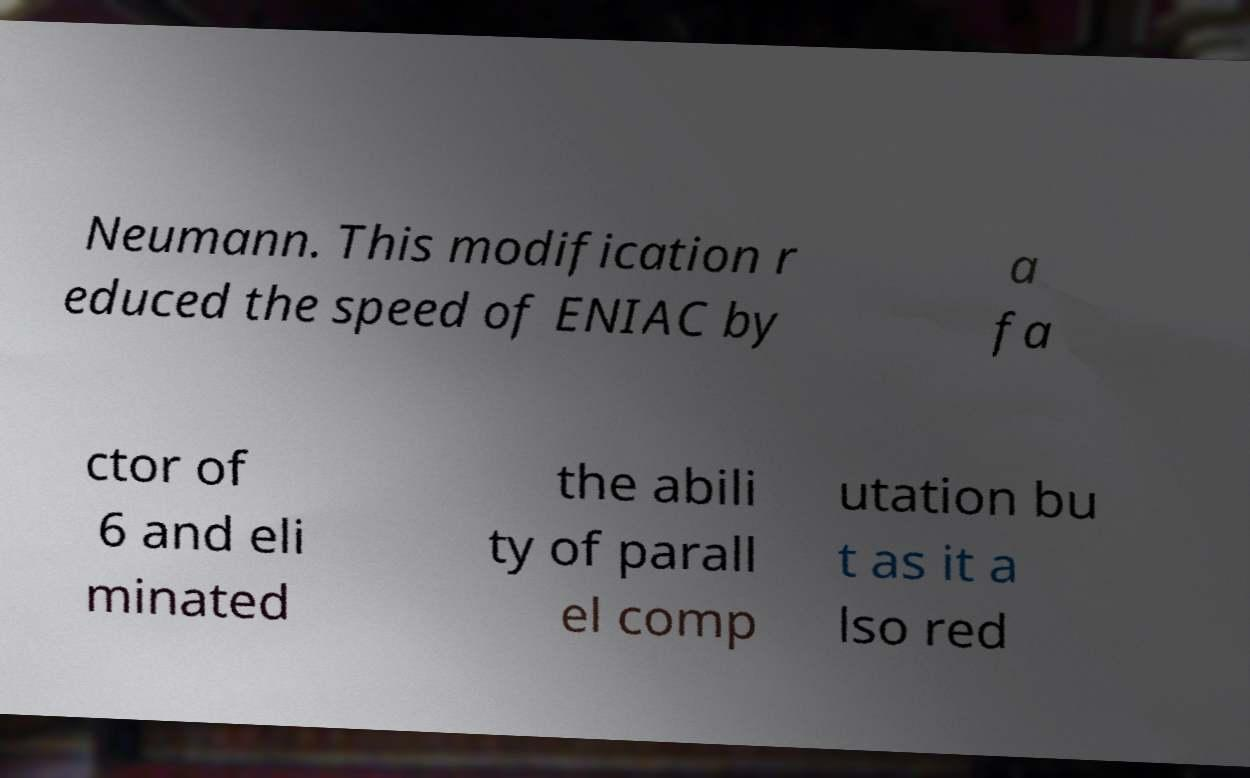What messages or text are displayed in this image? I need them in a readable, typed format. Neumann. This modification r educed the speed of ENIAC by a fa ctor of 6 and eli minated the abili ty of parall el comp utation bu t as it a lso red 